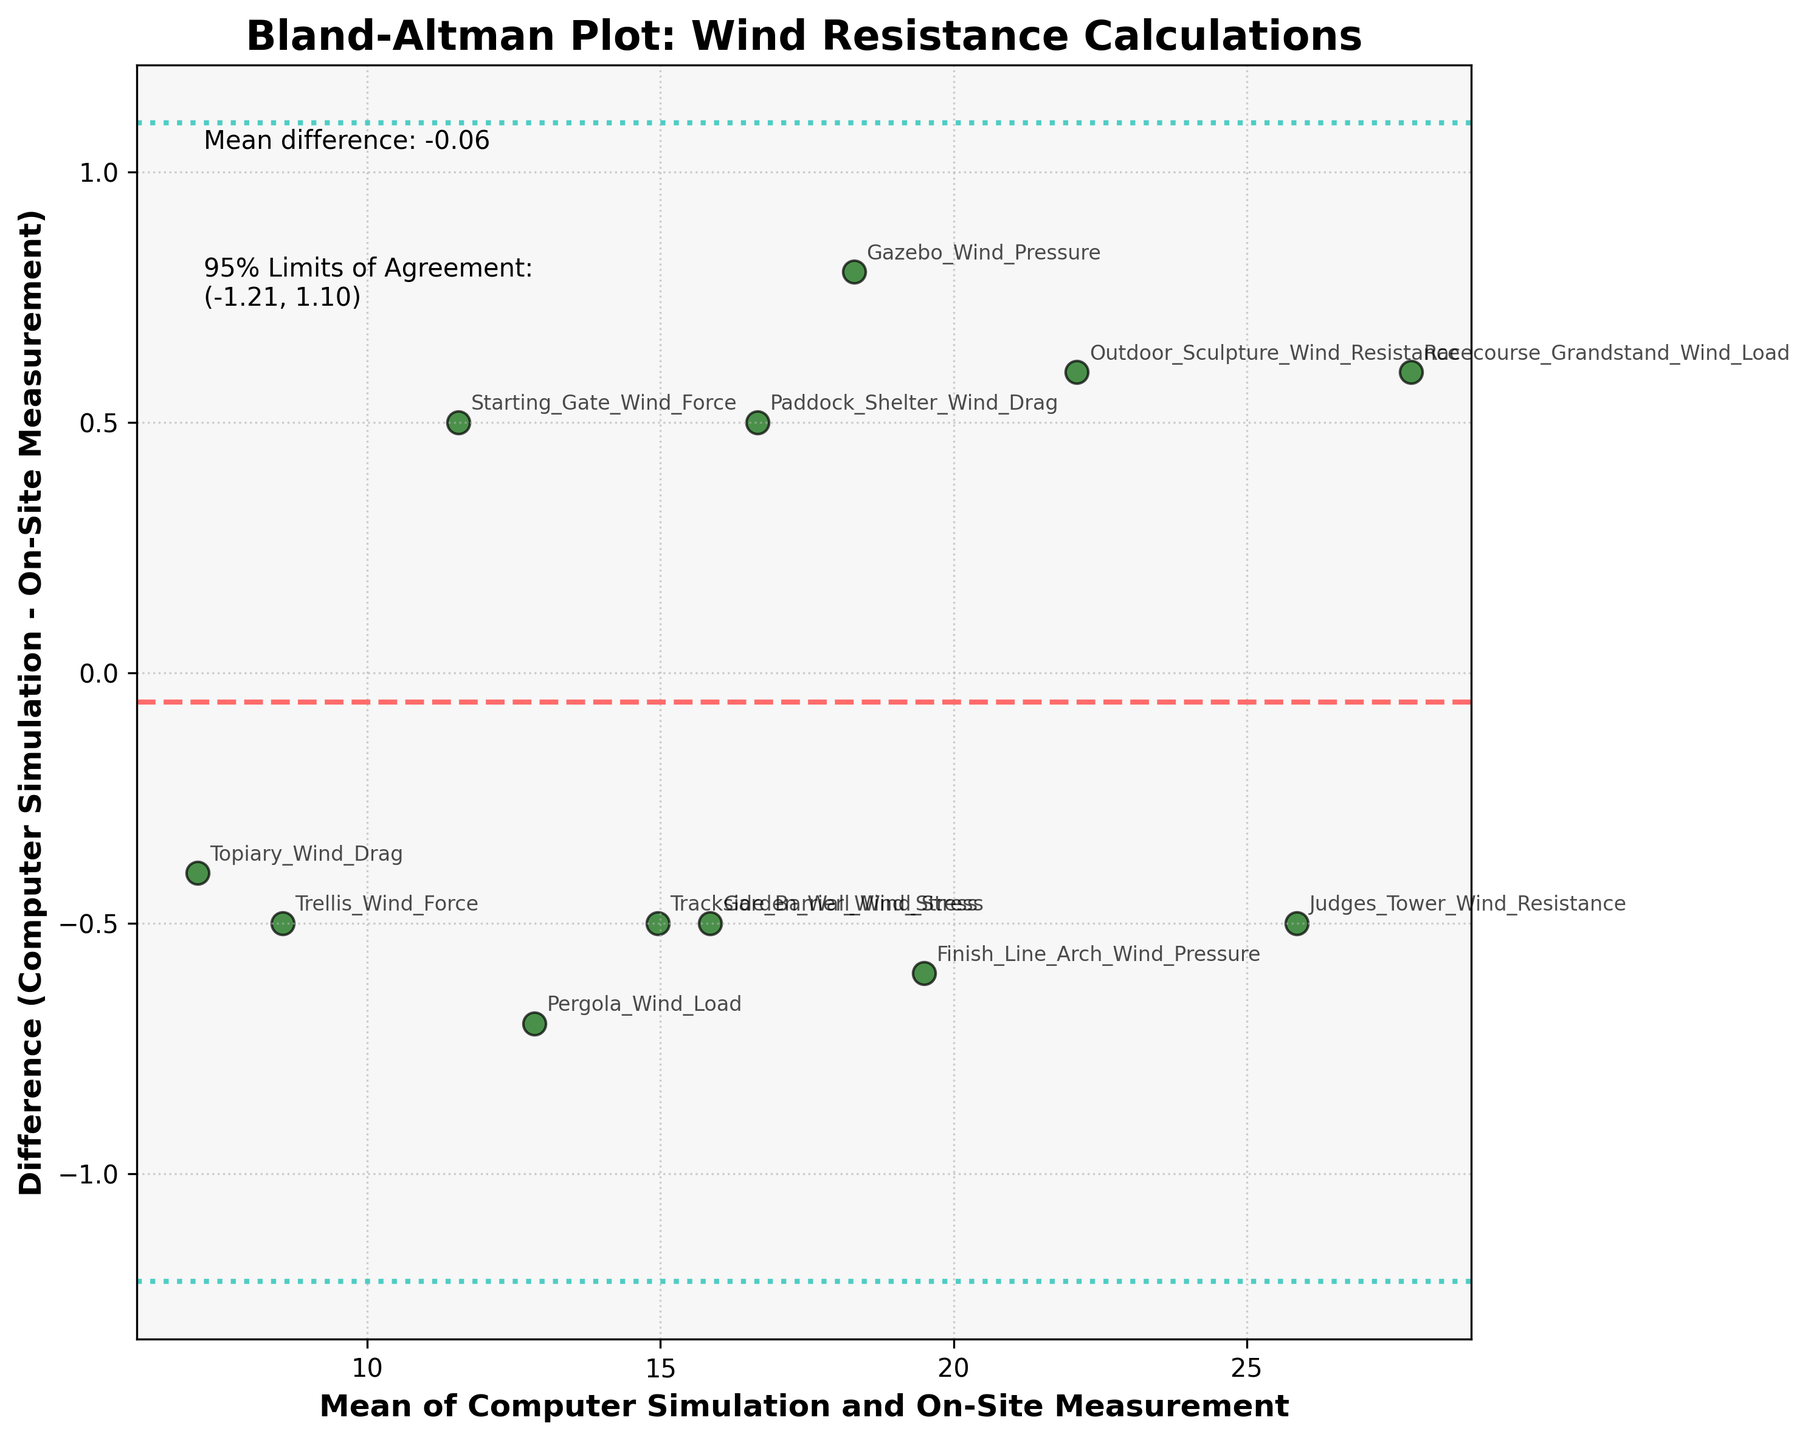Which methods show the most significant positive and negative differences? To determine the methods with the maximum positive and negative differences, we find the highest and lowest values on the y-axis. The Judges Tower has the highest positive difference, and the Starting Gate has the most profound negative difference.
Answer: Judges Tower and Starting Gate What is the title of the figure? The title can be read directly from the top of the figure.
Answer: Bland-Altman Plot: Wind Resistance Calculations What do the two dotted lines represent in the plot? The two dotted lines indicate the 95% Limits of Agreement for the differences between computer simulation and on-site measurements.
Answer: 95% Limits of Agreement What is the mean difference shown on the plot? The mean difference value is indicated by the dashed line and labeled annotation on the plot.
Answer: -0.12 Which method has the smallest average value of Computer Simulation and On-Site Measurement? The average value is calculated by (Computer_Simulation + On_Site_Measurement)/2. From the plot, we locate the method with the smallest x-axis value.
Answer: Topiary Wind Drag Are most of the differences between the limits of agreement? The differences are represented by the y-axis values. We observe if most of these values fall between the two dotted lines marking the limits of agreement.
Answer: Yes How many data points have differences greater than the mean difference? We count the number of points above the dashed horizontal line (mean difference) on the plot.
Answer: 6 Do the differences show any bias related to the mean of Computer Simulation and On-Site Measurement? To identify bias, we look for patterns or trends in the scatter plot, like a trend of points increasing or decreasing together.
Answer: No apparent bias What is the approximate range for the 95% Limits of Agreement? The range is given by the annotations near the dotted lines. It is computed as mean difference ± 1.96 * std_diff.
Answer: (-1.79, 1.55) Which methods have differences exactly at the mean difference? We identify which methods' differences are exactly on the dashed horizontal line indicating the mean difference.
Answer: Pergola Wind Load and Finish Line Arch 